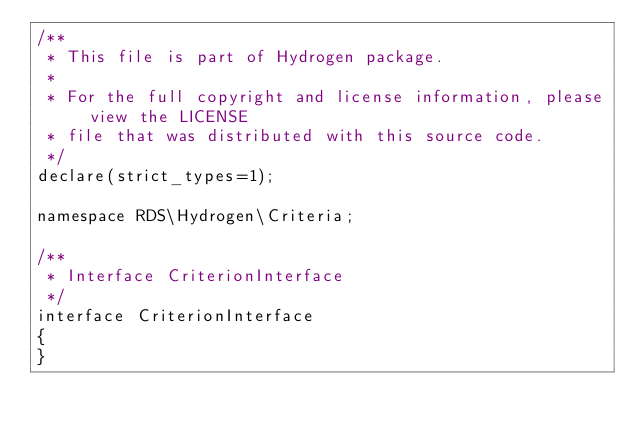Convert code to text. <code><loc_0><loc_0><loc_500><loc_500><_PHP_>/**
 * This file is part of Hydrogen package.
 *
 * For the full copyright and license information, please view the LICENSE
 * file that was distributed with this source code.
 */
declare(strict_types=1);

namespace RDS\Hydrogen\Criteria;

/**
 * Interface CriterionInterface
 */
interface CriterionInterface
{
}
</code> 